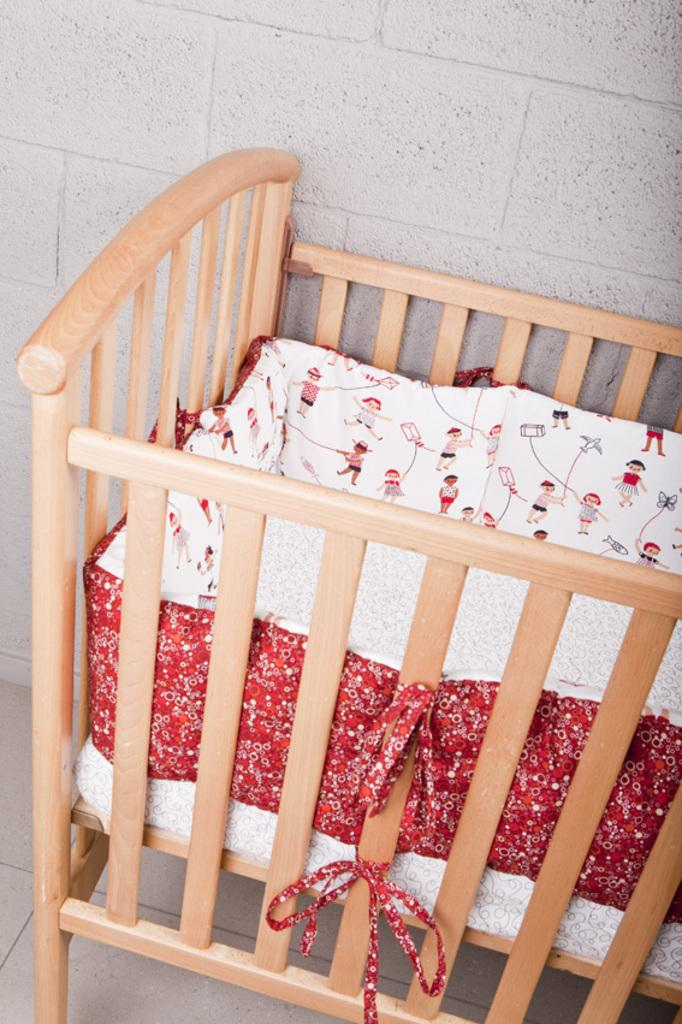What type of wooden object can be seen in the image? There is a wooden object that looks like a cradle in the image. What type of seat can be seen in the image? There is no seat present in the image; it features a wooden object that looks like a cradle. What type of lip can be seen in the image? There is no lip present in the image; it features a wooden object that looks like a cradle. 